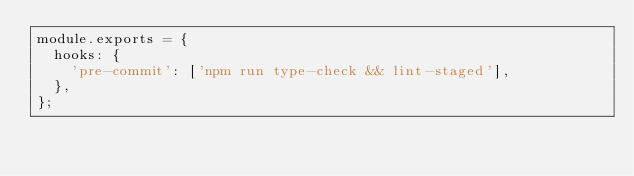Convert code to text. <code><loc_0><loc_0><loc_500><loc_500><_JavaScript_>module.exports = {
  hooks: {
    'pre-commit': ['npm run type-check && lint-staged'],
  },
};
</code> 